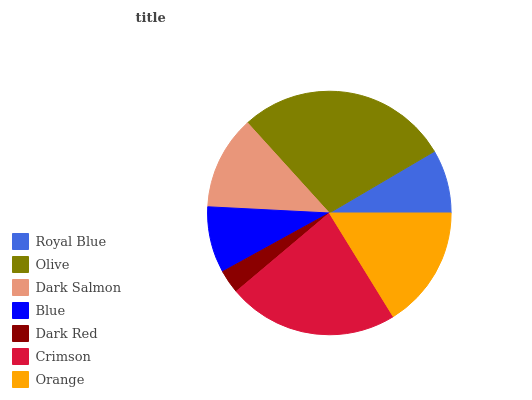Is Dark Red the minimum?
Answer yes or no. Yes. Is Olive the maximum?
Answer yes or no. Yes. Is Dark Salmon the minimum?
Answer yes or no. No. Is Dark Salmon the maximum?
Answer yes or no. No. Is Olive greater than Dark Salmon?
Answer yes or no. Yes. Is Dark Salmon less than Olive?
Answer yes or no. Yes. Is Dark Salmon greater than Olive?
Answer yes or no. No. Is Olive less than Dark Salmon?
Answer yes or no. No. Is Dark Salmon the high median?
Answer yes or no. Yes. Is Dark Salmon the low median?
Answer yes or no. Yes. Is Dark Red the high median?
Answer yes or no. No. Is Olive the low median?
Answer yes or no. No. 